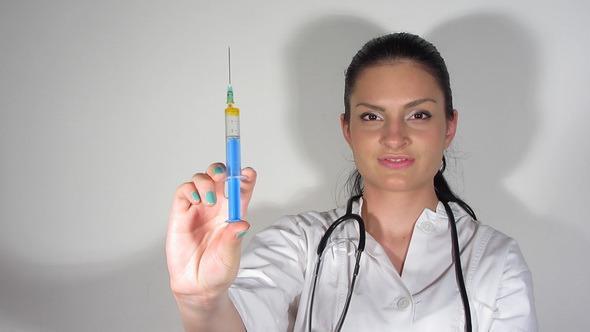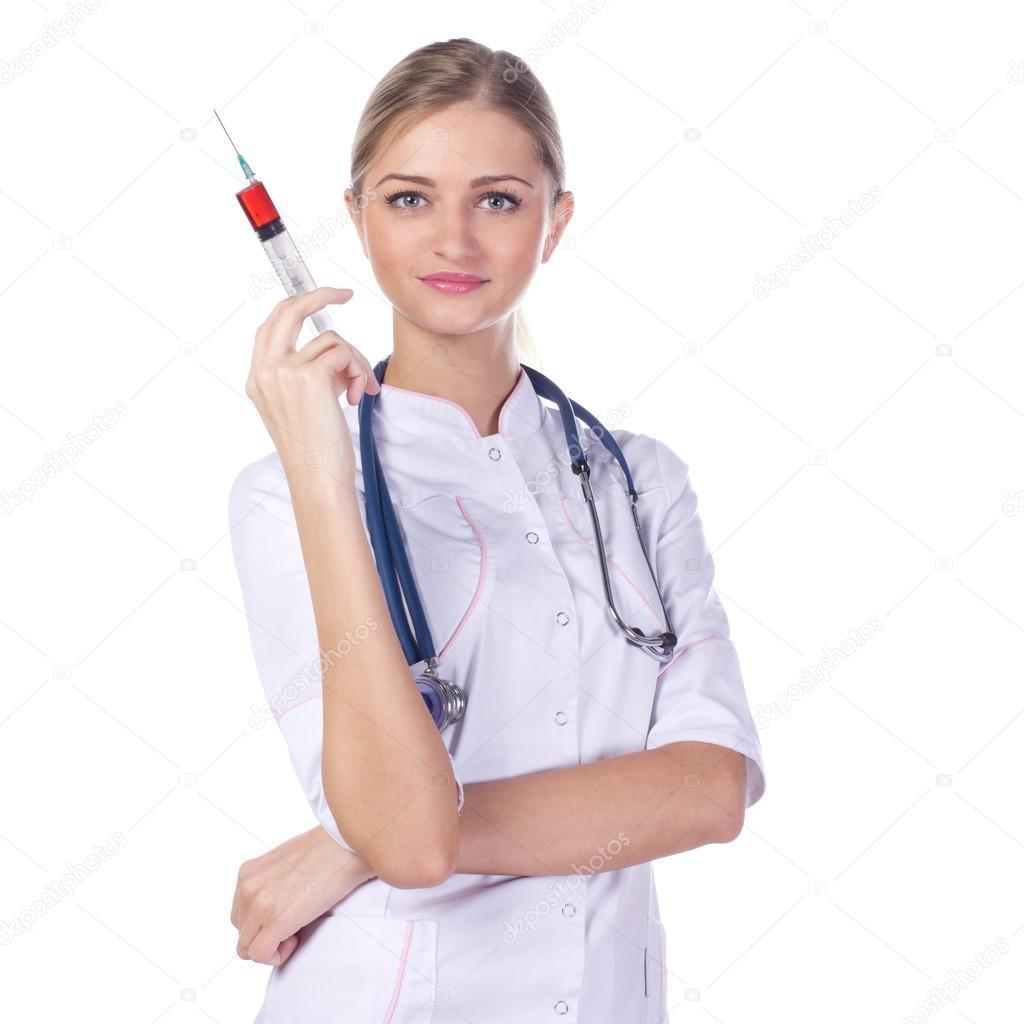The first image is the image on the left, the second image is the image on the right. For the images shown, is this caption "There are two women holding needles." true? Answer yes or no. Yes. The first image is the image on the left, the second image is the image on the right. Given the left and right images, does the statement "Two women are holding syringes." hold true? Answer yes or no. Yes. 